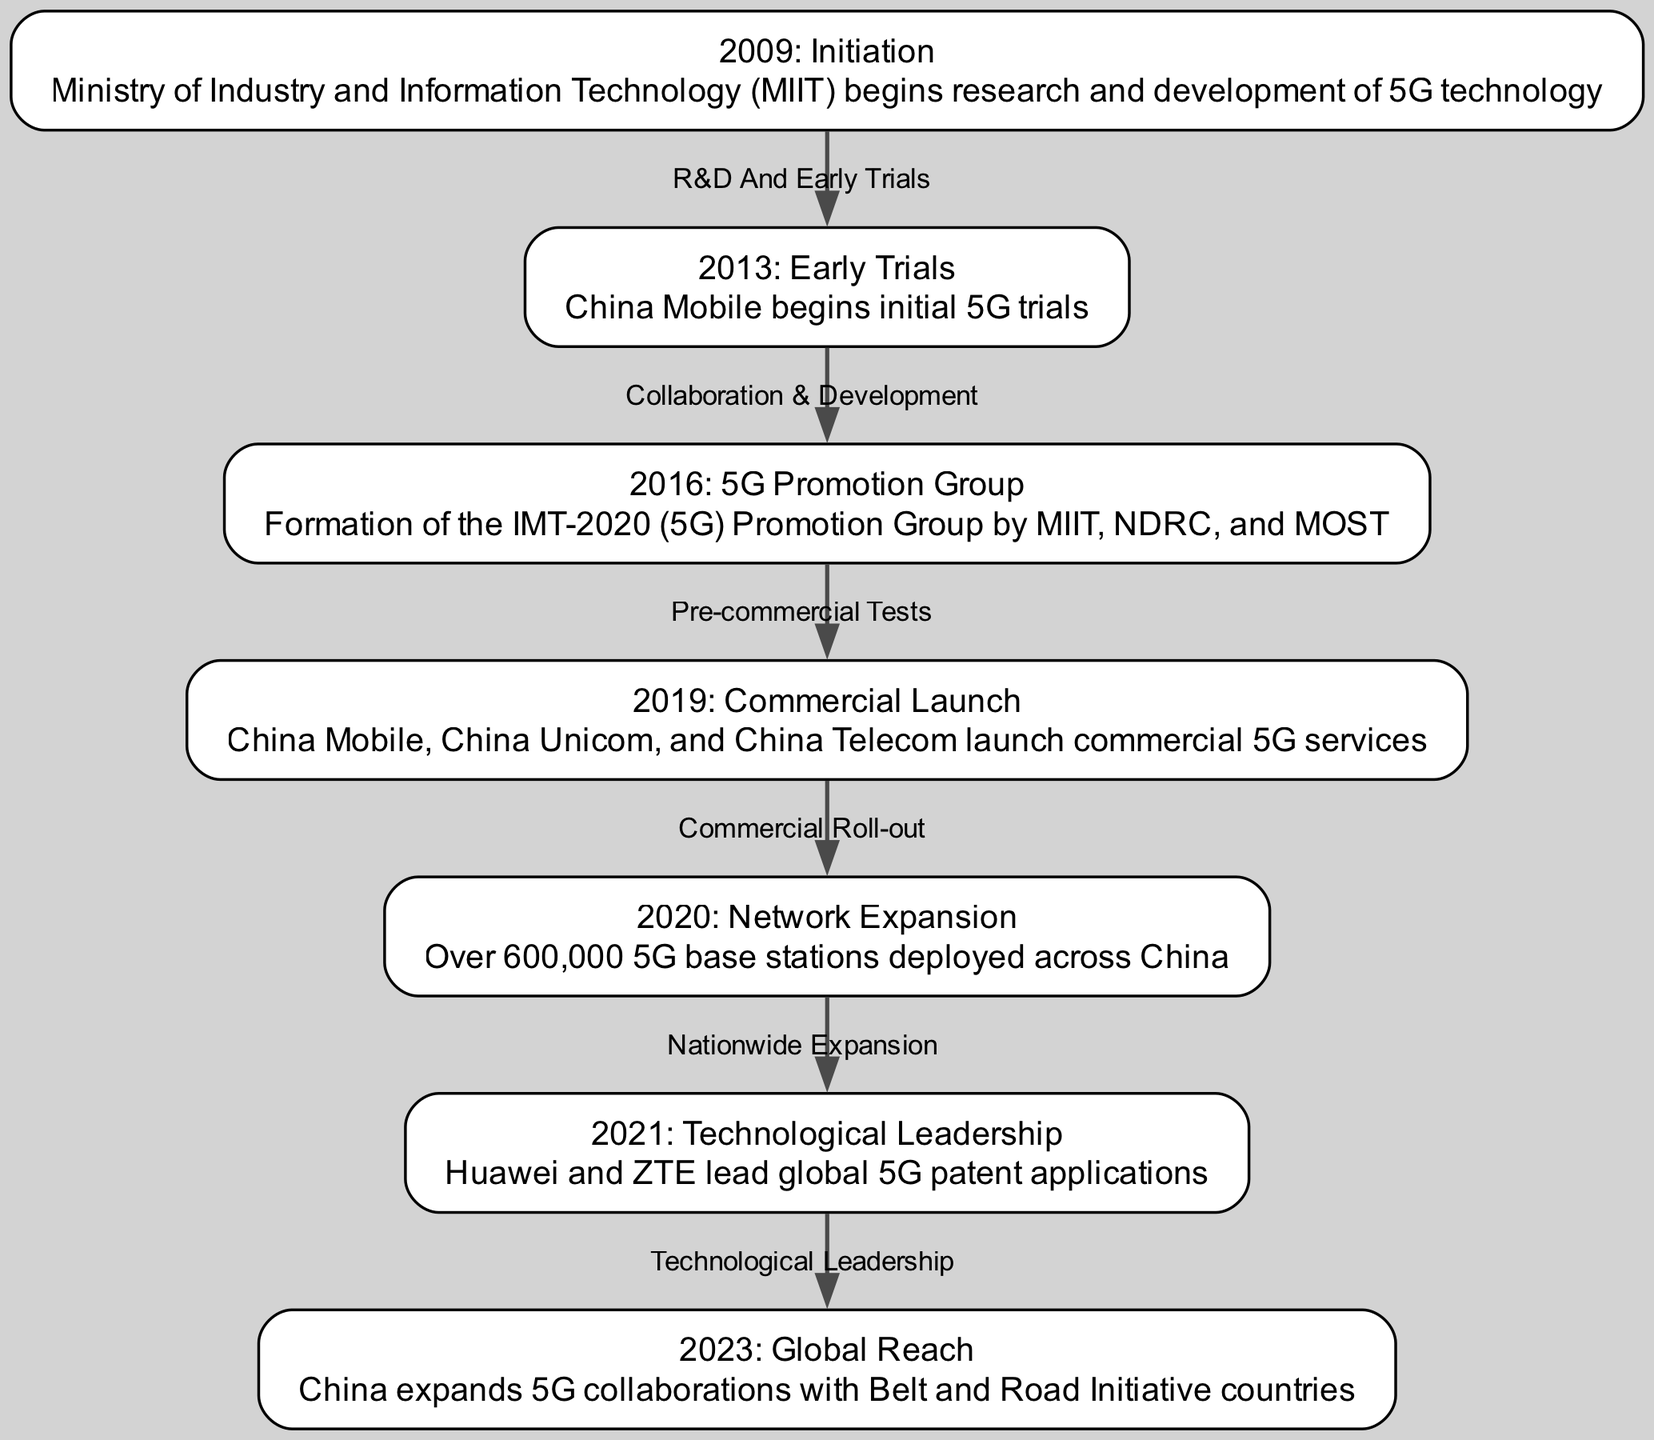What year did China begin research and development of 5G technology? The diagram indicates that the initiation of research and development for 5G technology began in 2009. This is stated clearly in the node labeled "2009: Initiation."
Answer: 2009 Which company launched commercial 5G services in 2019? The diagram's node labeled "2019: Commercial Launch" lists three companies: China Mobile, China Unicom, and China Telecom, indicating they all launched 5G services that year. Since the question requires a single company, any of those may suffice, but the first one listed is China Mobile.
Answer: China Mobile What milestone occurred in 2021 regarding patents? The node labeled "2021: Technological Leadership" notes that Huawei and ZTE led global 5G patent applications, highlighting a peak in technological leadership for these companies.
Answer: Huawei and ZTE How many 5G base stations were deployed across China in 2020? According to the "2020: Network Expansion" node, it states that over 600,000 5G base stations were deployed in that year. This is a specific number mentioned in the description.
Answer: Over 600,000 What relationship is depicted between the years 2016 and 2019? The edge connecting the nodes for 2016 and 2019 is labeled "Pre-commercial Tests." This indicates that there was collaboration and testing that led to developments prior to the commercial launch of 5G services in 2019.
Answer: Pre-commercial Tests What was formed in 2016 to promote 5G in China? The node labeled "2016: 5G Promotion Group" describes the formation of the IMT-2020 (5G) Promotion Group by MIIT, NDRC, and MOST, marking a significant organizational effort in 5G development.
Answer: IMT-2020 (5G) Promotion Group Which node represents the latest year in the diagram? The last node in the timeline sequence is labeled "2023: Global Reach," representing the most recent milestone achieved in the evolution of China's 5G deployment as shown in the diagram.
Answer: 2023 What does the edge between 2013 and 2016 signify? The edge between the nodes for 2013 and 2016 is labeled "Collaboration & Development," indicating a significant phase of cooperation and development taking place in the timeline of 5G technologies.
Answer: Collaboration & Development What significant international action regarding 5G did China take in 2023? The "2023: Global Reach" node notes that in this year, China expanded 5G collaborations with countries involved in the Belt and Road Initiative, marking a significant international outreach effort in the 5G domain.
Answer: Expand 5G collaborations 